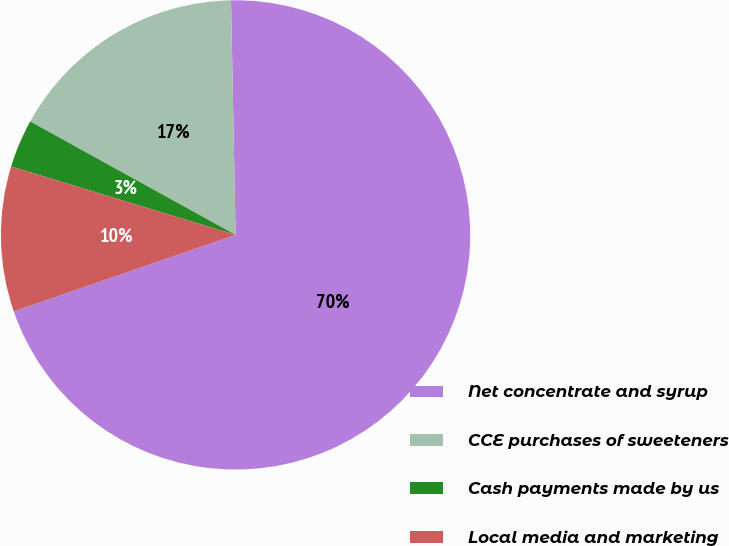<chart> <loc_0><loc_0><loc_500><loc_500><pie_chart><fcel>Net concentrate and syrup<fcel>CCE purchases of sweeteners<fcel>Cash payments made by us<fcel>Local media and marketing<nl><fcel>70.03%<fcel>16.66%<fcel>3.32%<fcel>9.99%<nl></chart> 